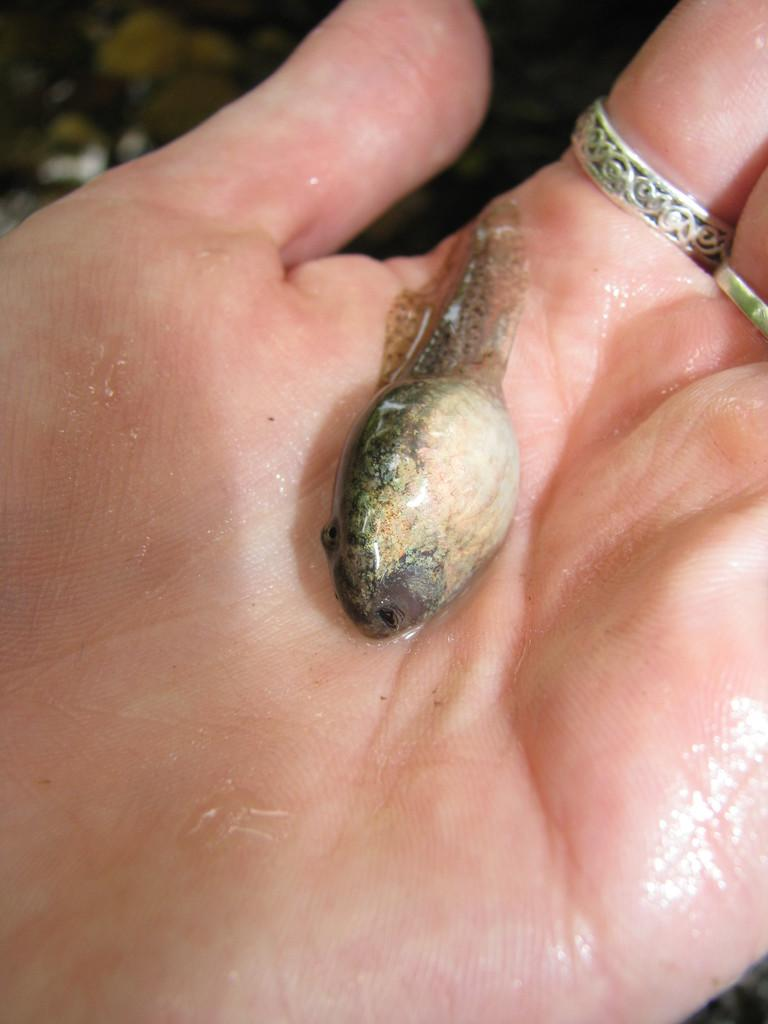What is the main subject of the image? There is a fish in the image. Where is the fish located? The fish is in a person's palm. What else can be seen on the person's hand? There are rings on the person's fingers. In which direction is the rice being cooked in the image? There is no rice present in the image, so it cannot be determined in which direction it would be cooked. 